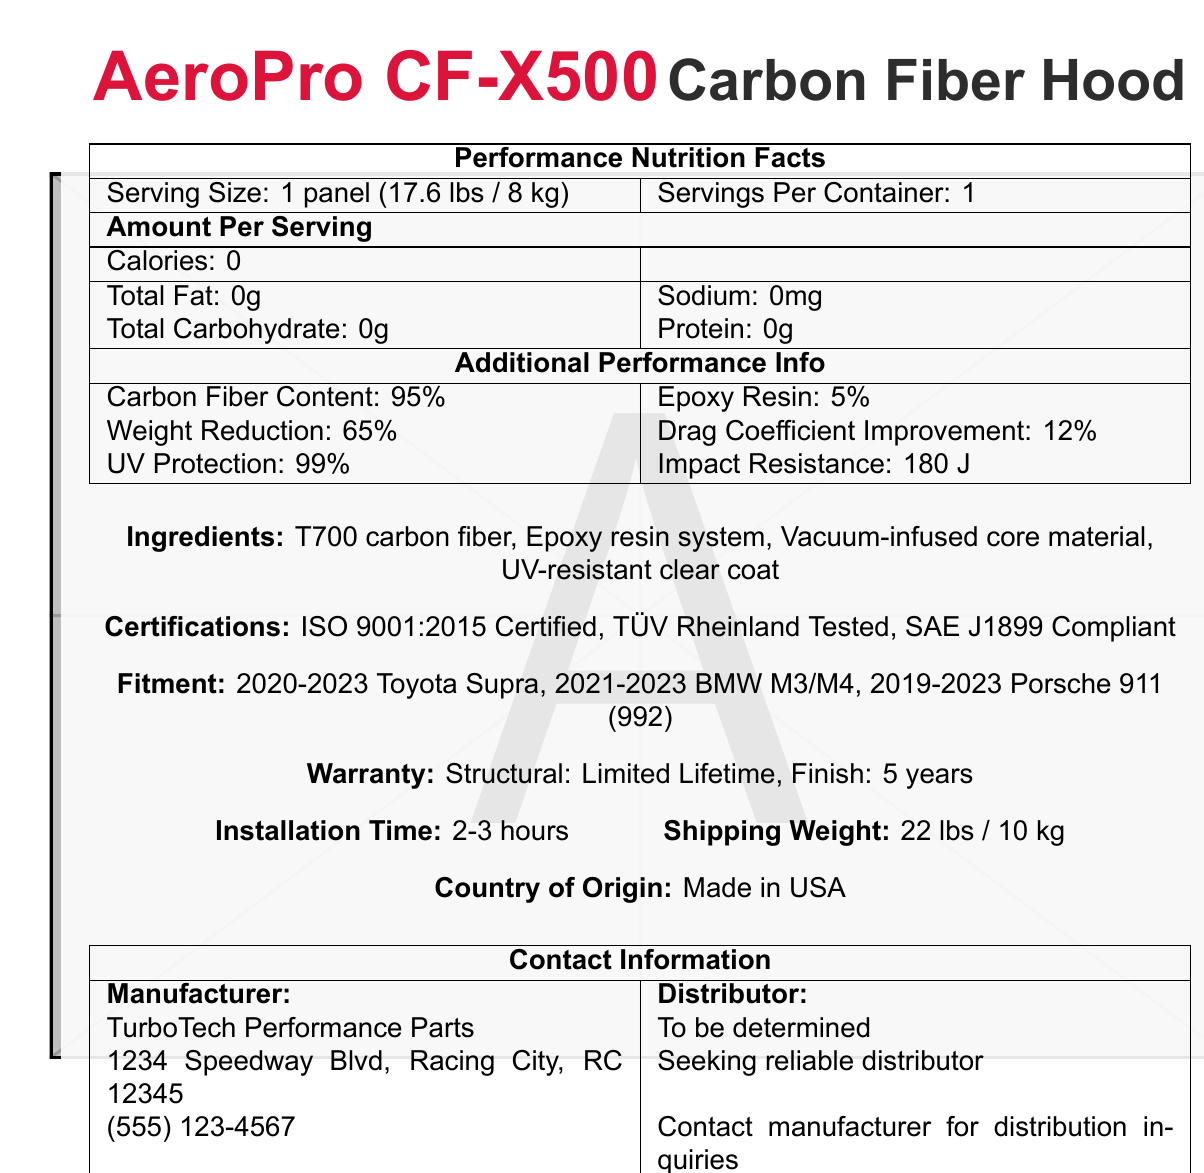What is the product name? The product name is clearly mentioned at the top of the document in bold text.
Answer: AeroPro CF-X500 Carbon Fiber Hood What is the serving size of the product? The serving size is listed under the nutrition facts section as "1 panel (17.6 lbs / 8 kg)".
Answer: 1 panel (17.6 lbs / 8 kg) How many servings per container are there? The document specifies "Servings Per Container: 1" directly in the nutrition facts section.
Answer: 1 What is the weight reduction percentage? Under the additional performance info, the weight reduction percentage is stated as "65%".
Answer: 65% Which cars is the AeroPro CF-X500 compatible with? The fitment section lists the compatible cars for the AeroPro CF-X500.
Answer: 2020-2023 Toyota Supra, 2021-2023 BMW M3/M4, 2019-2023 Porsche 911 (992) What certifications does the product have? A. ISO 9001:2015 Certified, B. TÜV Rheinland Tested, C. SAE J1899 Compliant, D. All of the above The certifications section confirms that the product has ISO 9001:2015, TÜV Rheinland, and SAE J1899 certifications.
Answer: D How long is the installation time? A. 1-2 hours B. 2-3 hours C. 3-4 hours D. 4-5 hours The document specifically states the installation time as "2-3 hours."
Answer: B Is the product made in the USA? The country of origin section lists "Made in USA."
Answer: Yes Summarize the main information given in the document. The document conveys comprehensive details about the AeroPro CF-X500 in various categories relevant to performance and compatibility, suitable for potential distributors.
Answer: The document provides detailed performance and certification information for the AeroPro CF-X500 Carbon Fiber Hood, including serving size, weight, additional materials information, certifications, fitment compatibility with certain car models, warranty details, installation time, shipping weight, and manufacturing origin. It seeks a distributor for the product. What is the impact resistance of the AeroPro CF-X500? The additional performance info section lists the impact resistance as "180 J."
Answer: 180 J Does the AeroPro CF-X500 provide UV protection? The additional performance info lists UV protection at "99%."
Answer: Yes, 99% UV protection What is the phone number for TurboTech Performance Parts? Under the contact information section, the phone number for the manufacturer TurboTech Performance Parts is listed as "(555) 123-4567."
Answer: (555) 123-4567 What is the ratio of carbon fiber content to epoxy resin in the AeroPro CF-X500? Under additional performance info, it states "Carbon Fiber Content: 95%" and "Epoxy Resin: 5%."
Answer: 95% carbon fiber and 5% epoxy resin Can you determine the price of the AeroPro CF-X500 from this document? There is no information provided in the document regarding the price of the AeroPro CF-X500.
Answer: Cannot be determined 